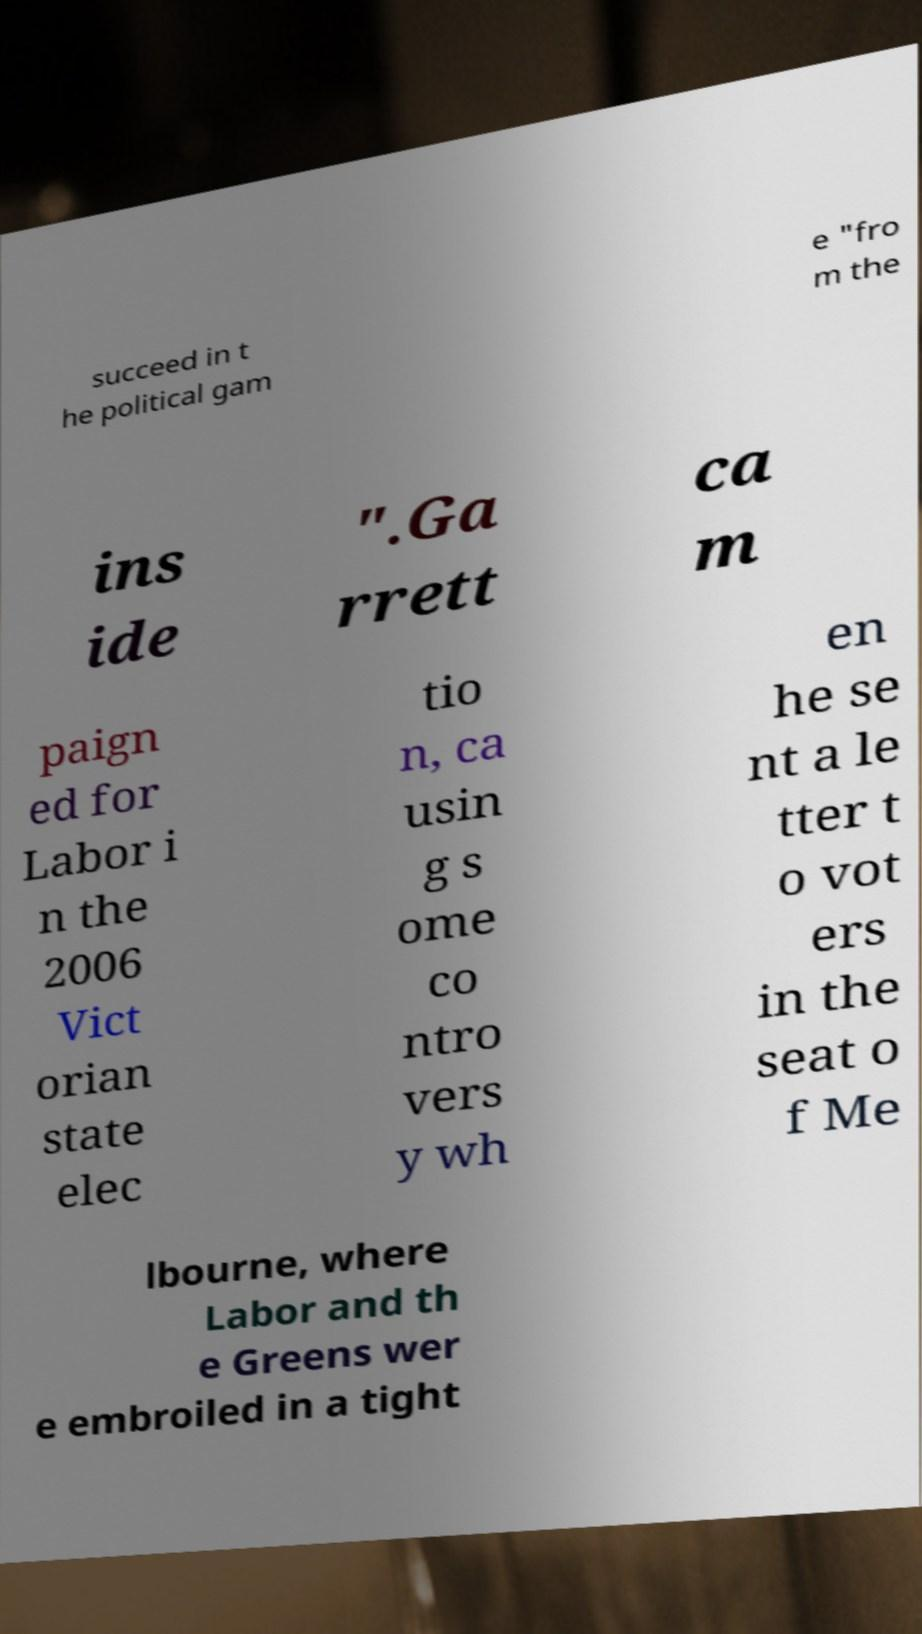For documentation purposes, I need the text within this image transcribed. Could you provide that? succeed in t he political gam e "fro m the ins ide ".Ga rrett ca m paign ed for Labor i n the 2006 Vict orian state elec tio n, ca usin g s ome co ntro vers y wh en he se nt a le tter t o vot ers in the seat o f Me lbourne, where Labor and th e Greens wer e embroiled in a tight 